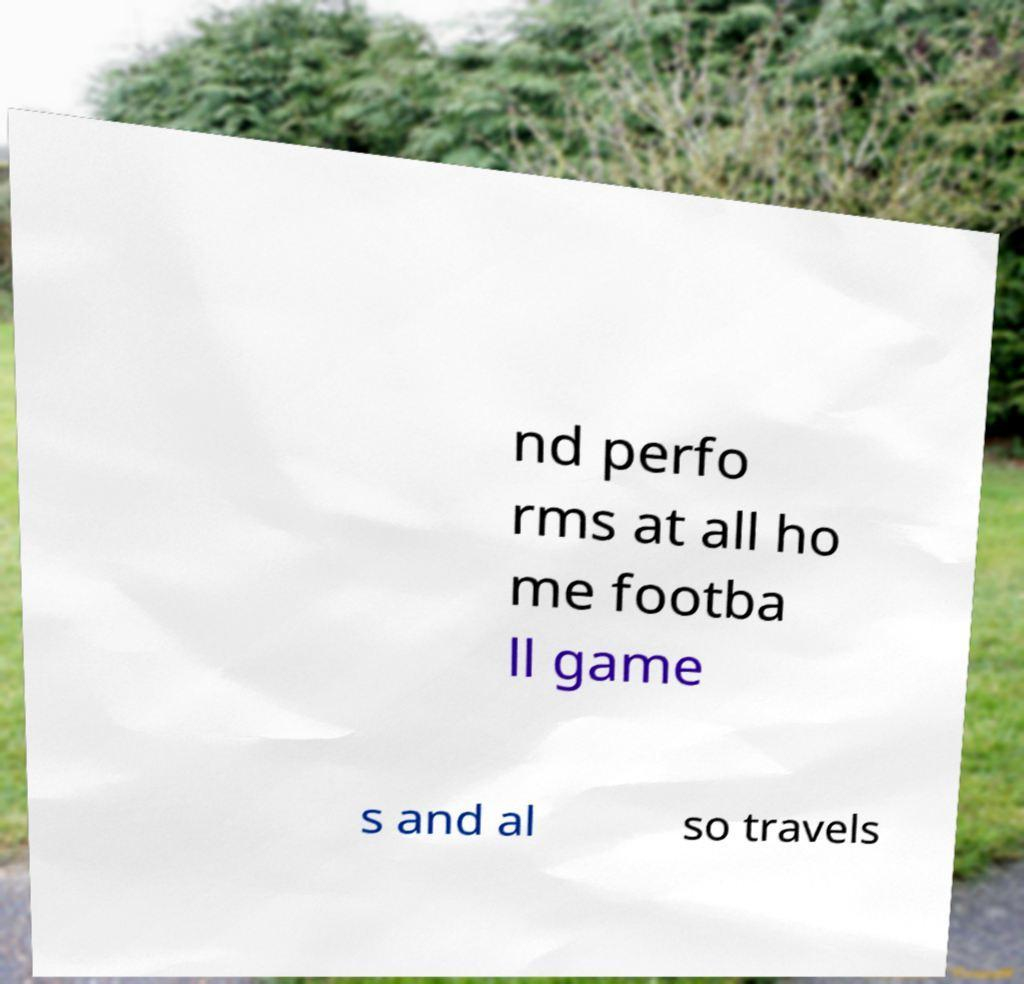Please identify and transcribe the text found in this image. nd perfo rms at all ho me footba ll game s and al so travels 